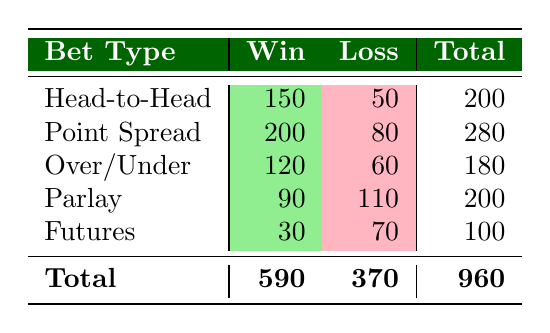What is the total number of Head-to-Head bets placed? The total number of Head-to-Head bets can be found by adding the wins and losses for that bet type. According to the table, Head-to-Head wins are 150 and losses are 50. Therefore, the total is 150 + 50 = 200.
Answer: 200 How many bets resulted in a loss for Point Spread? The number of losses for Point Spread is explicitly listed in the table. It shows 80 bets resulted in a loss.
Answer: 80 What is the average number of wins across all bet types? To find the average number of wins, first sum the wins from all bet types: 150 (H2H) + 200 (Point Spread) + 120 (Over/Under) + 90 (Parlay) + 30 (Futures) = 590. There are 5 bet types, so the average number of wins is 590/5 = 118.
Answer: 118 Are there more wins for Over/Under bets than for Futures bets? The table shows that Over/Under has 120 wins, while Futures has only 30 wins. Since 120 is greater than 30, the answer is yes.
Answer: Yes If a customer placed all types of bets, what percentage of them were wins? The total number of wins is 590, and the total number of bets placed (wins + losses) is 960. To find the percentage of wins, calculate (590/960) * 100 = 61.46%.
Answer: 61.46% Which bet type has the highest number of wins? By comparing the number of wins for each bet type, Point Spread has the highest with 200 wins, while Head-to-Head has 150, Over/Under has 120, Parlay has 90, and Futures has 30. So the highest is Point Spread.
Answer: Point Spread How many more losses did Parlay bets have than Over/Under bets? The Parlay bets have 110 losses, while the Over/Under bets have 60 losses. To find the difference, we subtract: 110 - 60 = 50.
Answer: 50 What fraction of total bets placed were losses? The total number of losses is 370 and total bets placed is 960. The fraction of losses can be calculated as 370/960. This can be simplified to 37/96.
Answer: 37/96 Is the total number of bets placed across all types even or odd? The total number of bets placed is 960. Since 960 ends with a zero, it is even.
Answer: Even 